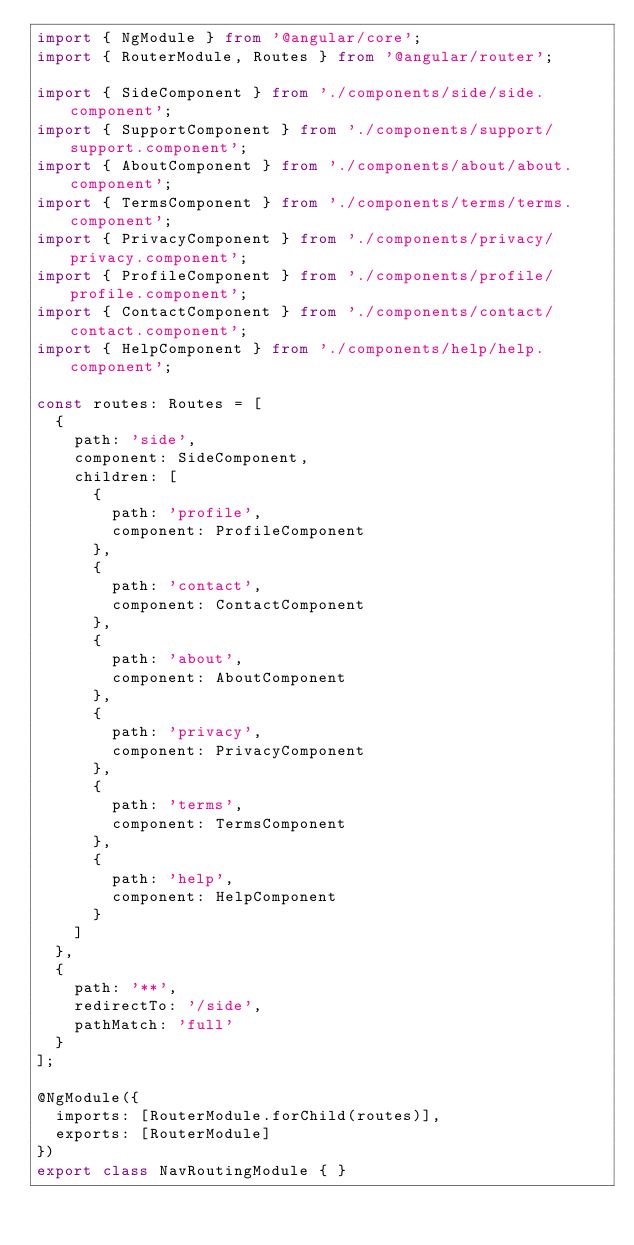<code> <loc_0><loc_0><loc_500><loc_500><_TypeScript_>import { NgModule } from '@angular/core';
import { RouterModule, Routes } from '@angular/router';

import { SideComponent } from './components/side/side.component';
import { SupportComponent } from './components/support/support.component';
import { AboutComponent } from './components/about/about.component';
import { TermsComponent } from './components/terms/terms.component';
import { PrivacyComponent } from './components/privacy/privacy.component';
import { ProfileComponent } from './components/profile/profile.component';
import { ContactComponent } from './components/contact/contact.component';
import { HelpComponent } from './components/help/help.component';

const routes: Routes = [
  {
    path: 'side',
    component: SideComponent,
    children: [
      {
        path: 'profile',
        component: ProfileComponent
      },
      {
        path: 'contact',
        component: ContactComponent
      },
      {
        path: 'about',
        component: AboutComponent
      },
      {
        path: 'privacy',
        component: PrivacyComponent
      },
      {
        path: 'terms',
        component: TermsComponent
      },
      {
        path: 'help',
        component: HelpComponent
      }
    ]
  },
  {
    path: '**',
    redirectTo: '/side',
    pathMatch: 'full'
  }
];

@NgModule({
  imports: [RouterModule.forChild(routes)],
  exports: [RouterModule]
})
export class NavRoutingModule { }
</code> 